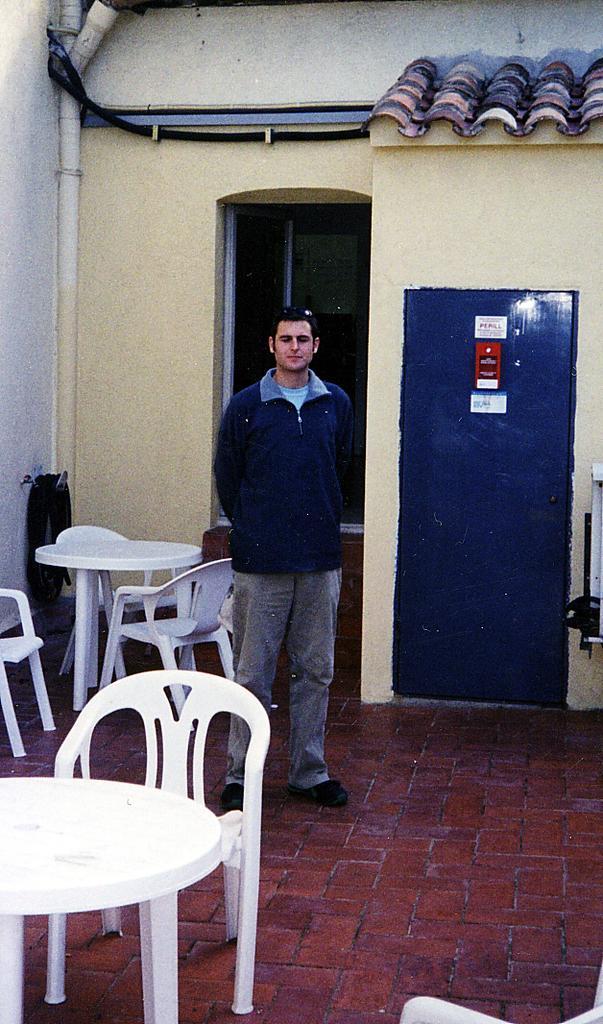Can you describe this image briefly? The person wearing blue jacket is standing and there are tables and chairs in front and behind him and the background wall is yellow in color. 